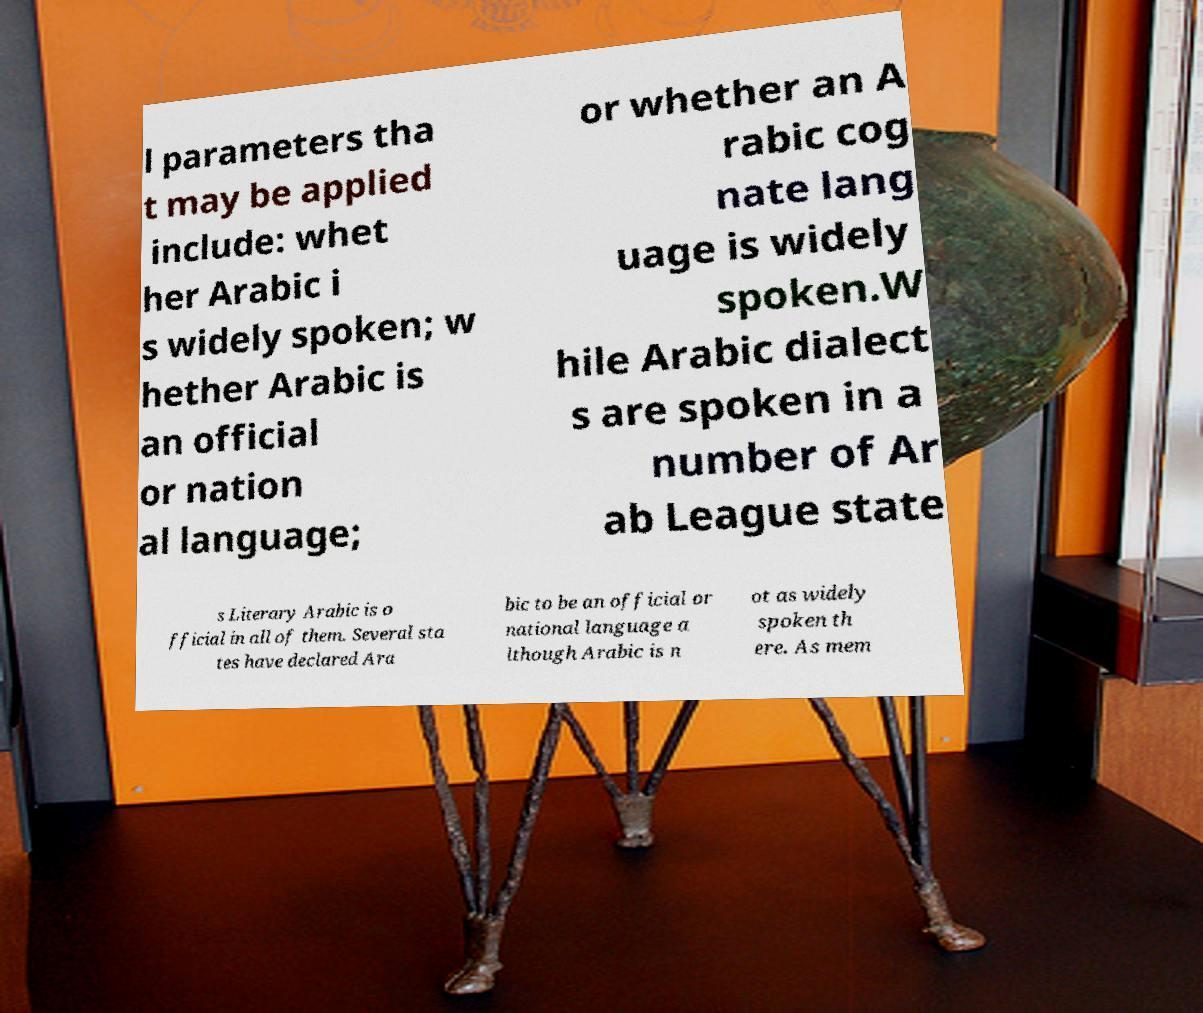For documentation purposes, I need the text within this image transcribed. Could you provide that? l parameters tha t may be applied include: whet her Arabic i s widely spoken; w hether Arabic is an official or nation al language; or whether an A rabic cog nate lang uage is widely spoken.W hile Arabic dialect s are spoken in a number of Ar ab League state s Literary Arabic is o fficial in all of them. Several sta tes have declared Ara bic to be an official or national language a lthough Arabic is n ot as widely spoken th ere. As mem 